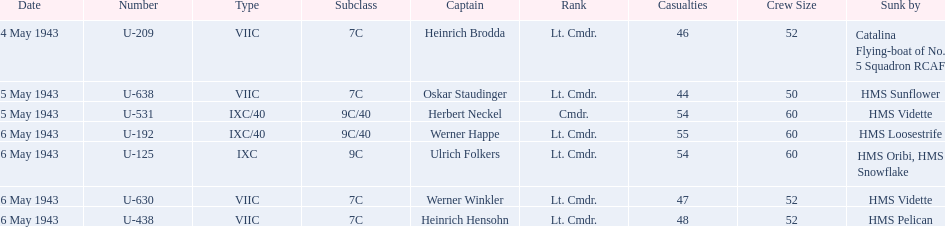How many more casualties occurred on may 6 compared to may 4? 158. I'm looking to parse the entire table for insights. Could you assist me with that? {'header': ['Date', 'Number', 'Type', 'Subclass', 'Captain', 'Rank', 'Casualties', 'Crew Size', 'Sunk by'], 'rows': [['4 May 1943', 'U-209', 'VIIC', '7C', 'Heinrich Brodda', 'Lt. Cmdr.', '46', '52', 'Catalina Flying-boat of No. 5 Squadron RCAF'], ['5 May 1943', 'U-638', 'VIIC', '7C', 'Oskar Staudinger', 'Lt. Cmdr.', '44', '50', 'HMS Sunflower'], ['5 May 1943', 'U-531', 'IXC/40', '9C/40', 'Herbert Neckel', 'Cmdr.', '54', '60', 'HMS Vidette'], ['6 May 1943', 'U-192', 'IXC/40', '9C/40', 'Werner Happe', 'Lt. Cmdr.', '55', '60', 'HMS Loosestrife'], ['6 May 1943', 'U-125', 'IXC', '9C', 'Ulrich Folkers', 'Lt. Cmdr.', '54', '60', 'HMS Oribi, HMS Snowflake'], ['6 May 1943', 'U-630', 'VIIC', '7C', 'Werner Winkler', 'Lt. Cmdr.', '47', '52', 'HMS Vidette'], ['6 May 1943', 'U-438', 'VIIC', '7C', 'Heinrich Hensohn', 'Lt. Cmdr.', '48', '52', 'HMS Pelican']]} 